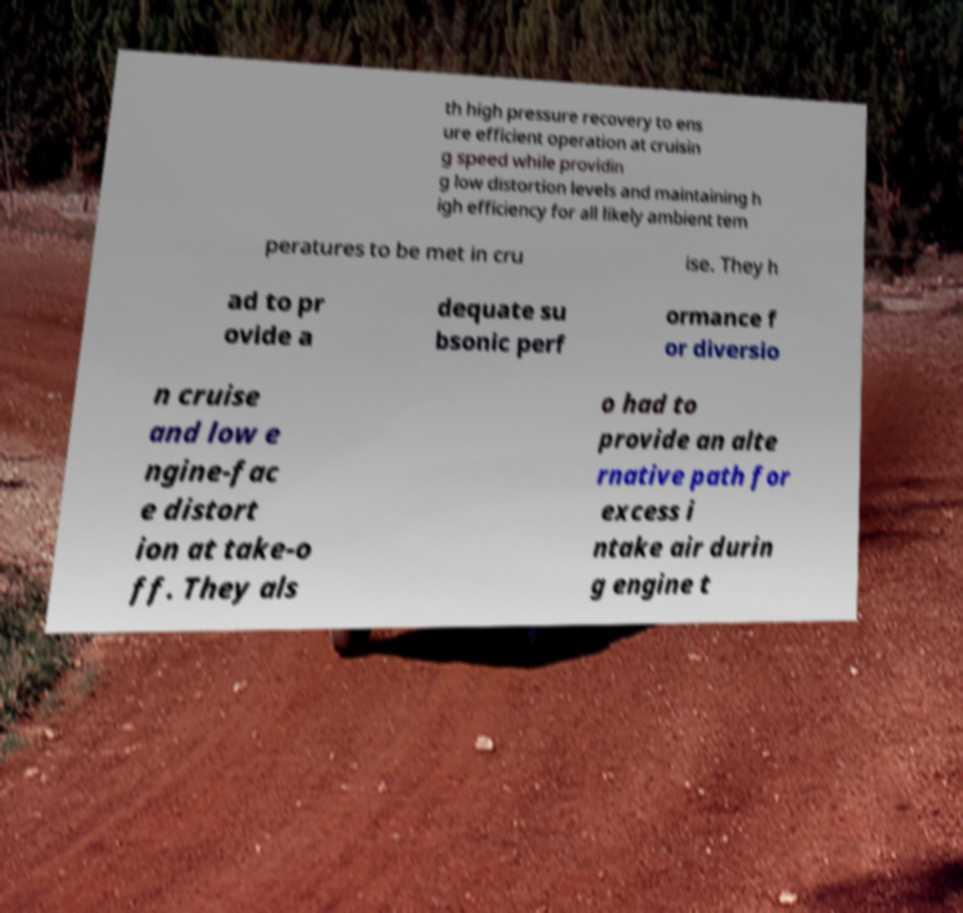For documentation purposes, I need the text within this image transcribed. Could you provide that? th high pressure recovery to ens ure efficient operation at cruisin g speed while providin g low distortion levels and maintaining h igh efficiency for all likely ambient tem peratures to be met in cru ise. They h ad to pr ovide a dequate su bsonic perf ormance f or diversio n cruise and low e ngine-fac e distort ion at take-o ff. They als o had to provide an alte rnative path for excess i ntake air durin g engine t 